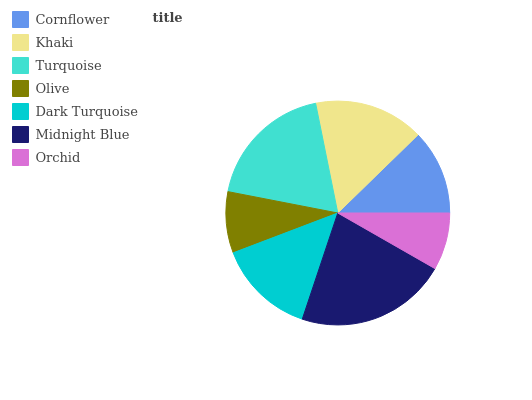Is Orchid the minimum?
Answer yes or no. Yes. Is Midnight Blue the maximum?
Answer yes or no. Yes. Is Khaki the minimum?
Answer yes or no. No. Is Khaki the maximum?
Answer yes or no. No. Is Khaki greater than Cornflower?
Answer yes or no. Yes. Is Cornflower less than Khaki?
Answer yes or no. Yes. Is Cornflower greater than Khaki?
Answer yes or no. No. Is Khaki less than Cornflower?
Answer yes or no. No. Is Dark Turquoise the high median?
Answer yes or no. Yes. Is Dark Turquoise the low median?
Answer yes or no. Yes. Is Cornflower the high median?
Answer yes or no. No. Is Turquoise the low median?
Answer yes or no. No. 